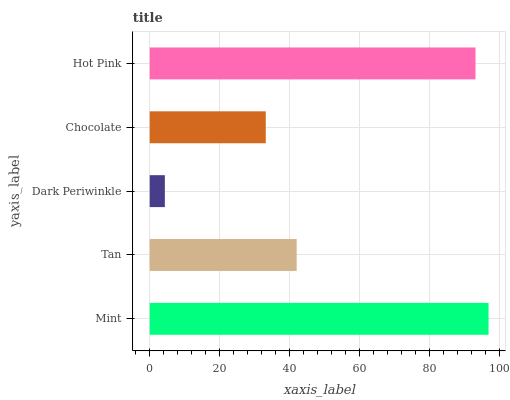Is Dark Periwinkle the minimum?
Answer yes or no. Yes. Is Mint the maximum?
Answer yes or no. Yes. Is Tan the minimum?
Answer yes or no. No. Is Tan the maximum?
Answer yes or no. No. Is Mint greater than Tan?
Answer yes or no. Yes. Is Tan less than Mint?
Answer yes or no. Yes. Is Tan greater than Mint?
Answer yes or no. No. Is Mint less than Tan?
Answer yes or no. No. Is Tan the high median?
Answer yes or no. Yes. Is Tan the low median?
Answer yes or no. Yes. Is Mint the high median?
Answer yes or no. No. Is Chocolate the low median?
Answer yes or no. No. 